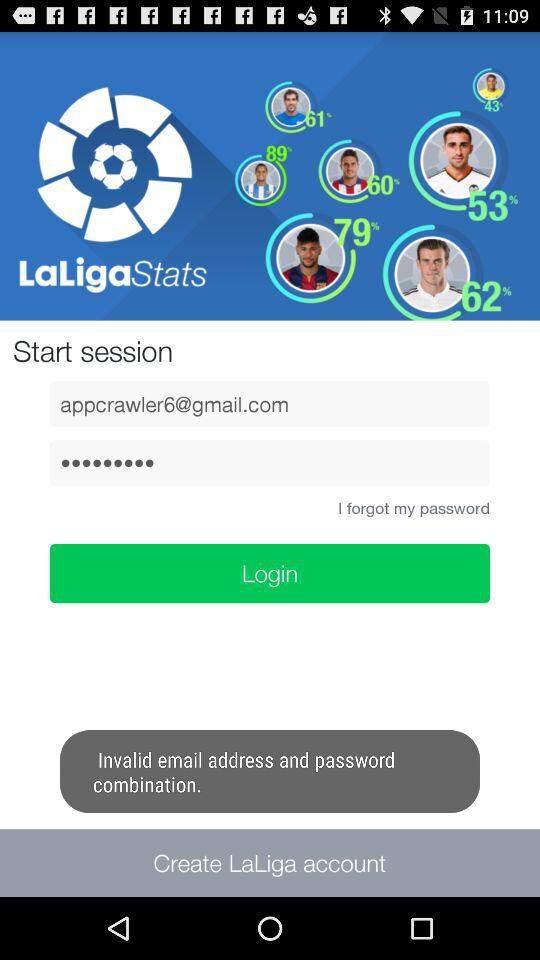What’s the app's name? The app's name is "LaLigaStats". 